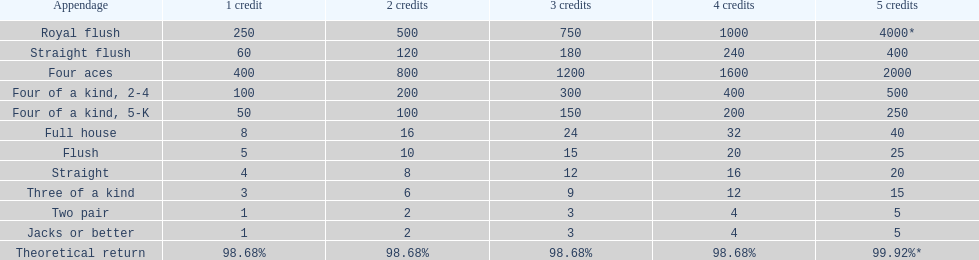The number of credits returned for a one credit bet on a royal flush are. 250. 